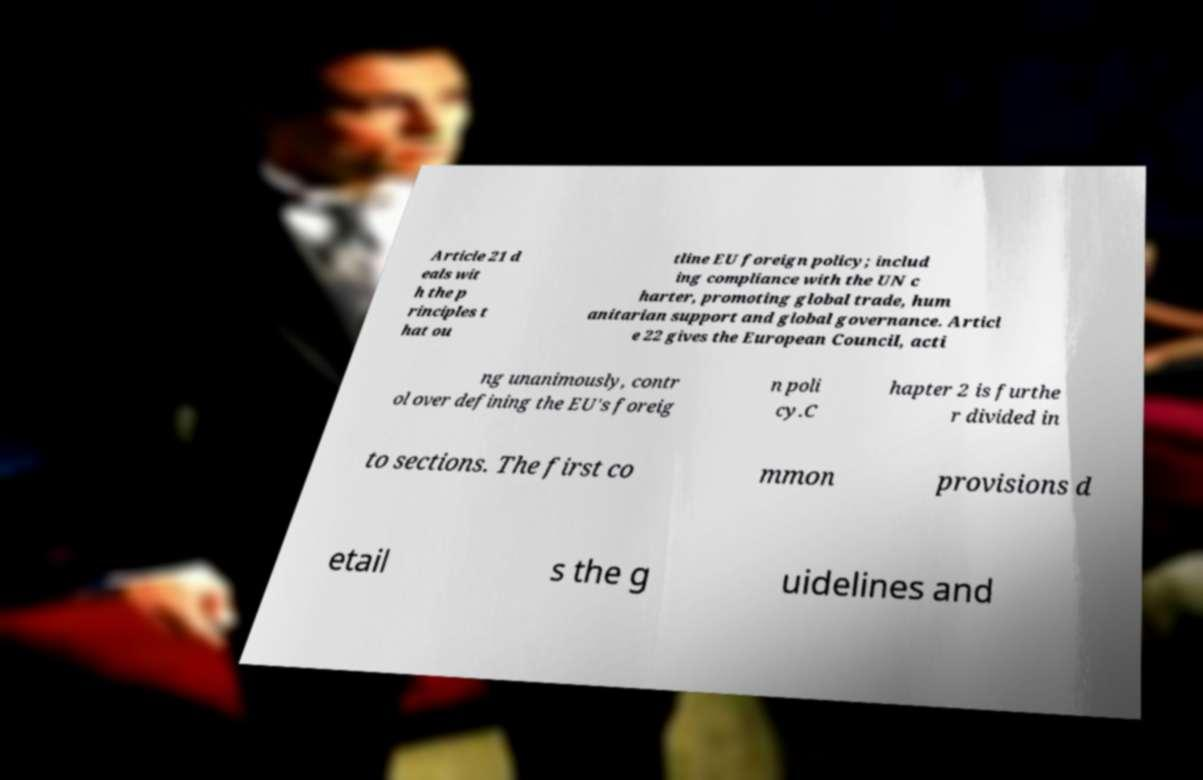Please identify and transcribe the text found in this image. Article 21 d eals wit h the p rinciples t hat ou tline EU foreign policy; includ ing compliance with the UN c harter, promoting global trade, hum anitarian support and global governance. Articl e 22 gives the European Council, acti ng unanimously, contr ol over defining the EU's foreig n poli cy.C hapter 2 is furthe r divided in to sections. The first co mmon provisions d etail s the g uidelines and 